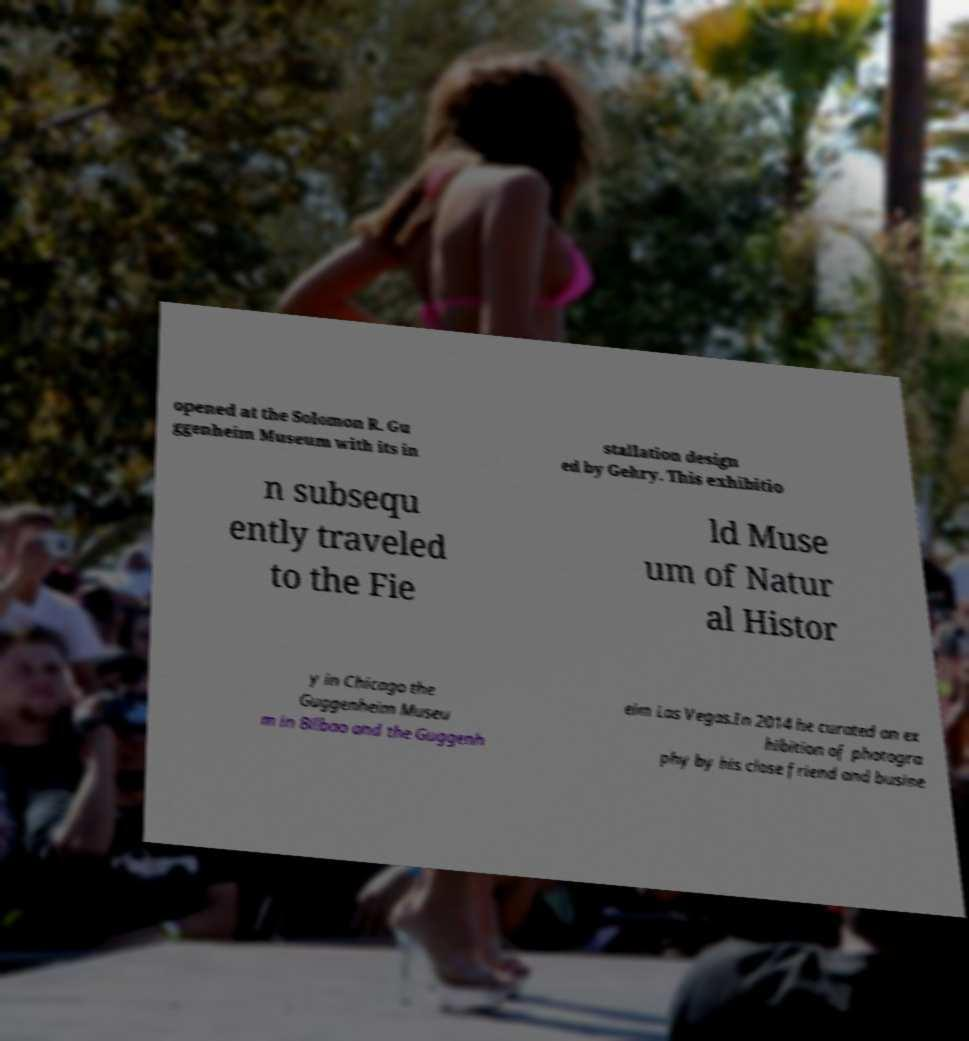Can you accurately transcribe the text from the provided image for me? opened at the Solomon R. Gu ggenheim Museum with its in stallation design ed by Gehry. This exhibitio n subsequ ently traveled to the Fie ld Muse um of Natur al Histor y in Chicago the Guggenheim Museu m in Bilbao and the Guggenh eim Las Vegas.In 2014 he curated an ex hibition of photogra phy by his close friend and busine 